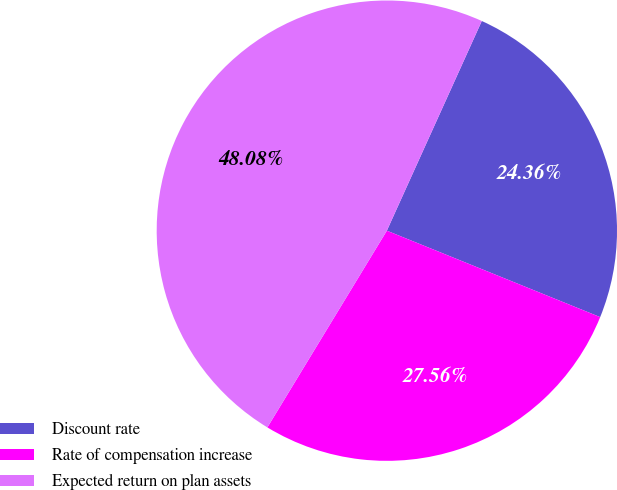<chart> <loc_0><loc_0><loc_500><loc_500><pie_chart><fcel>Discount rate<fcel>Rate of compensation increase<fcel>Expected return on plan assets<nl><fcel>24.36%<fcel>27.56%<fcel>48.08%<nl></chart> 